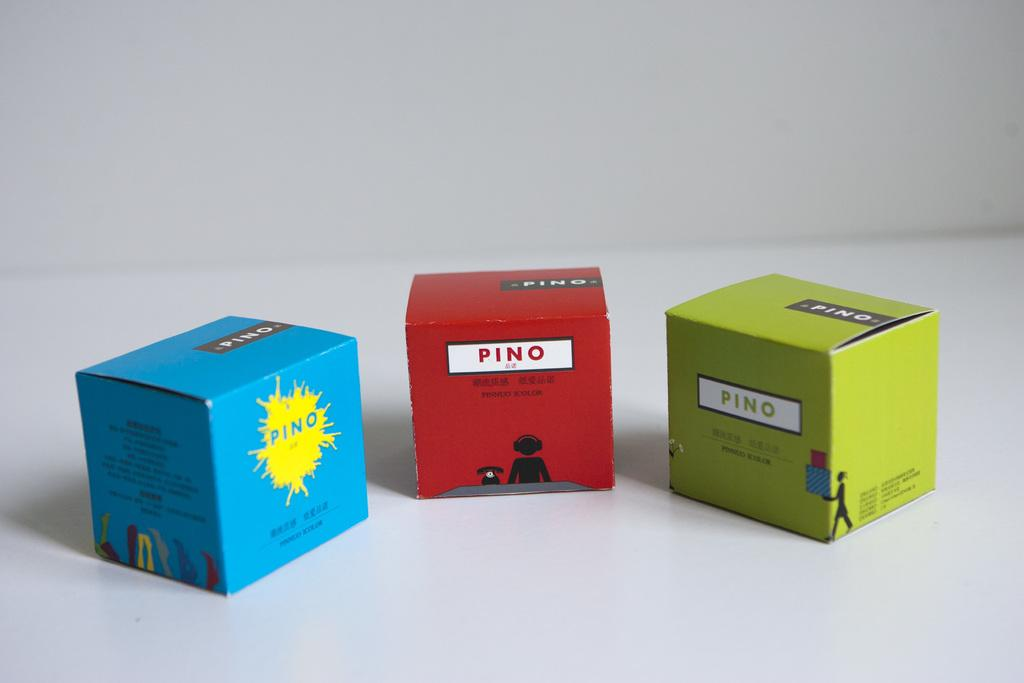<image>
Summarize the visual content of the image. Three boxes with the word Pino on them are arranged in a curved row. 